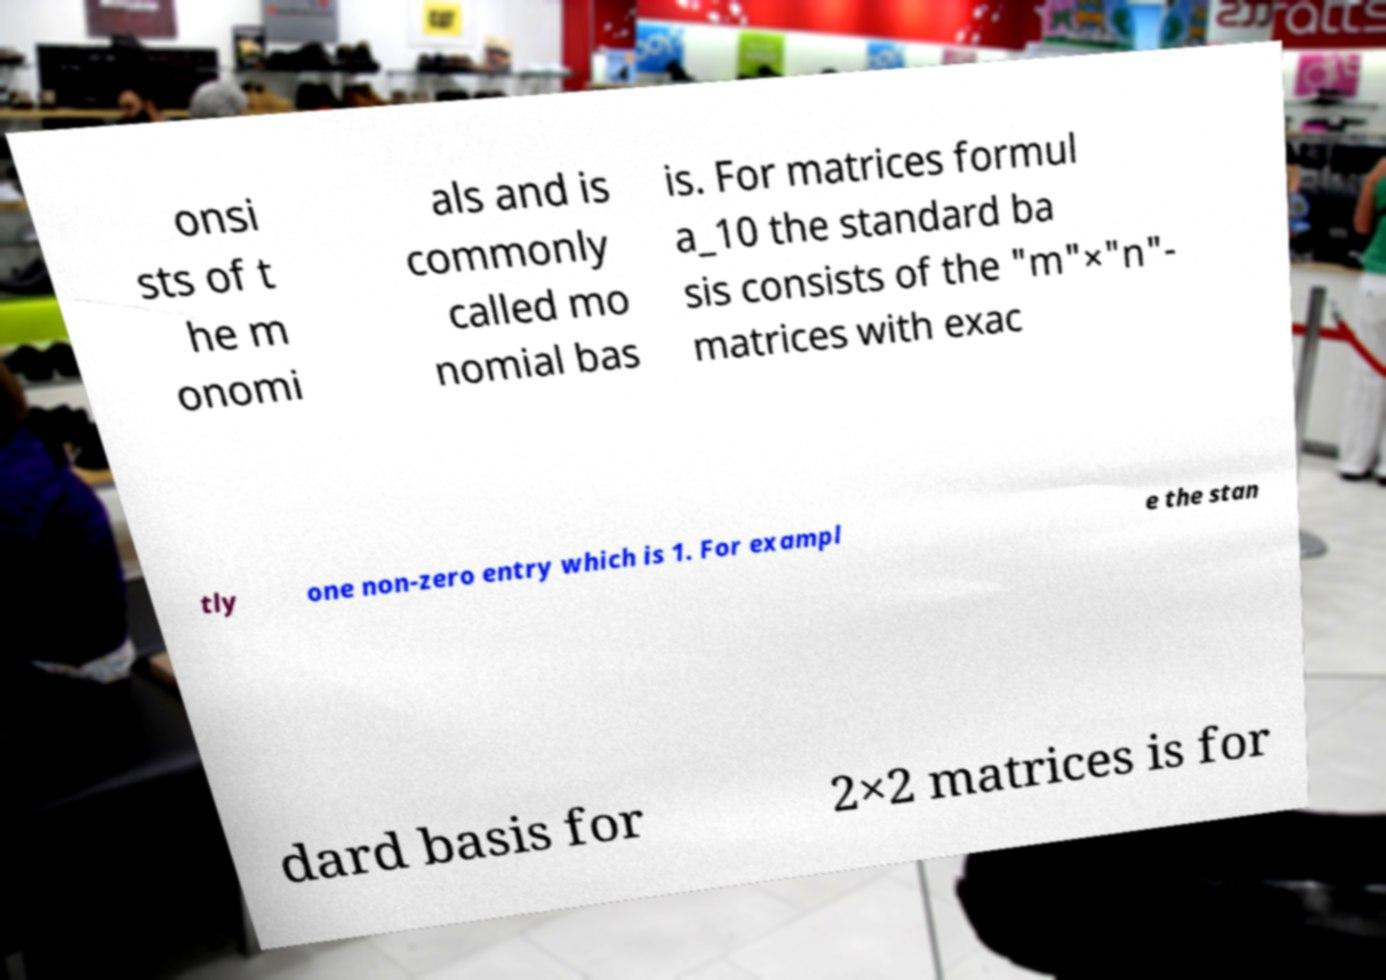I need the written content from this picture converted into text. Can you do that? onsi sts of t he m onomi als and is commonly called mo nomial bas is. For matrices formul a_10 the standard ba sis consists of the "m"×"n"- matrices with exac tly one non-zero entry which is 1. For exampl e the stan dard basis for 2×2 matrices is for 